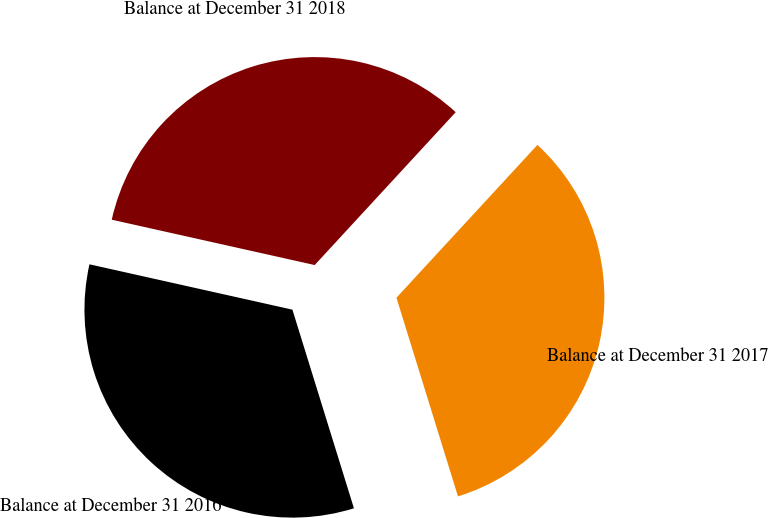Convert chart. <chart><loc_0><loc_0><loc_500><loc_500><pie_chart><fcel>Balance at December 31 2016<fcel>Balance at December 31 2017<fcel>Balance at December 31 2018<nl><fcel>33.28%<fcel>33.36%<fcel>33.36%<nl></chart> 